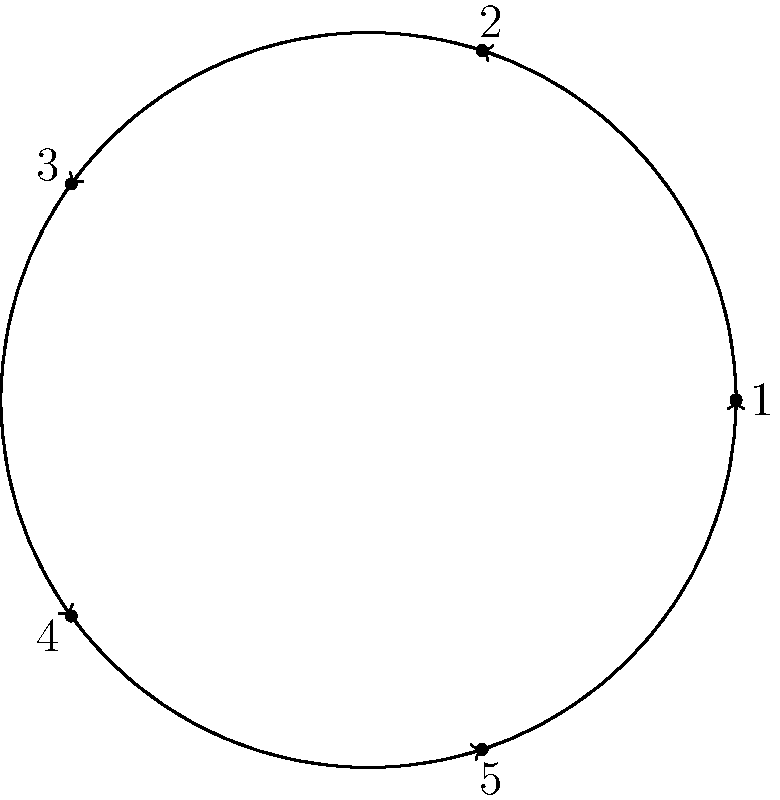Consider the assembly process of a vintage fountain pen, where the order of assembly is represented by a cyclic group of order 5. The elements are numbered as follows:
1. Nib
2. Feed
3. Barrel
4. Cap
5. Ink Reservoir

If we start with the nib (1) and apply the group operation three times, which component will we end up on? To solve this problem, we need to follow these steps:

1. Understand the cyclic group representation:
   - The assembly process is represented by a cyclic group of order 5.
   - Each element corresponds to a component of the fountain pen.
   - The group operation moves us from one element to the next in a cyclic manner.

2. Identify the starting point:
   - We begin with the nib, which is element 1 in our cyclic group.

3. Apply the group operation three times:
   - First application: 1 (Nib) → 2 (Feed)
   - Second application: 2 (Feed) → 3 (Barrel)
   - Third application: 3 (Barrel) → 4 (Cap)

4. Interpret the result:
   - After applying the operation three times, we end up on element 4, which corresponds to the Cap.

In terms of group theory, this operation can be expressed as $g^3(1)$, where $g$ is the generator of the cyclic group, and 1 is our starting element (the nib). The result $g^3(1) = 4$ in this cyclic group of order 5.
Answer: Cap 